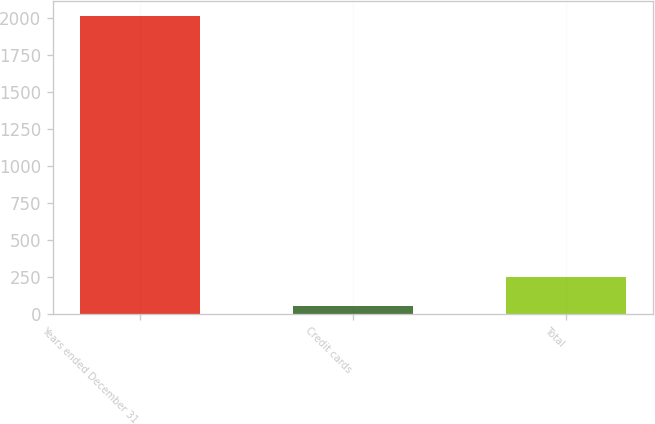Convert chart to OTSL. <chart><loc_0><loc_0><loc_500><loc_500><bar_chart><fcel>Years ended December 31<fcel>Credit cards<fcel>Total<nl><fcel>2013<fcel>56<fcel>251.7<nl></chart> 